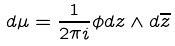Convert formula to latex. <formula><loc_0><loc_0><loc_500><loc_500>d \mu = \frac { 1 } { 2 \pi i } \phi d z \wedge d \overline { z }</formula> 